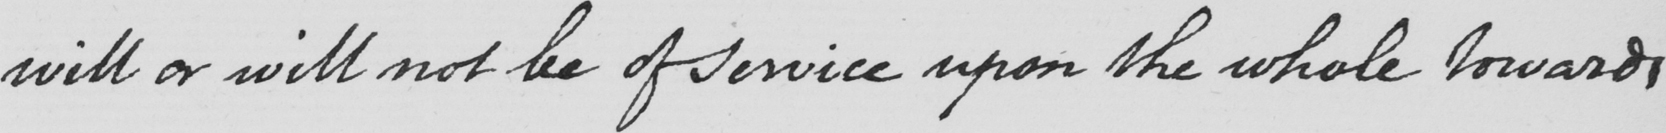Please provide the text content of this handwritten line. will or will not be of service upon the whole towards 